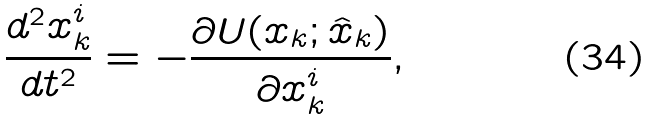<formula> <loc_0><loc_0><loc_500><loc_500>\frac { d ^ { 2 } x _ { k } ^ { i } } { d t ^ { 2 } } = - \frac { \partial U ( x _ { k } ; \hat { x } _ { k } ) } { \partial x _ { k } ^ { i } } ,</formula> 